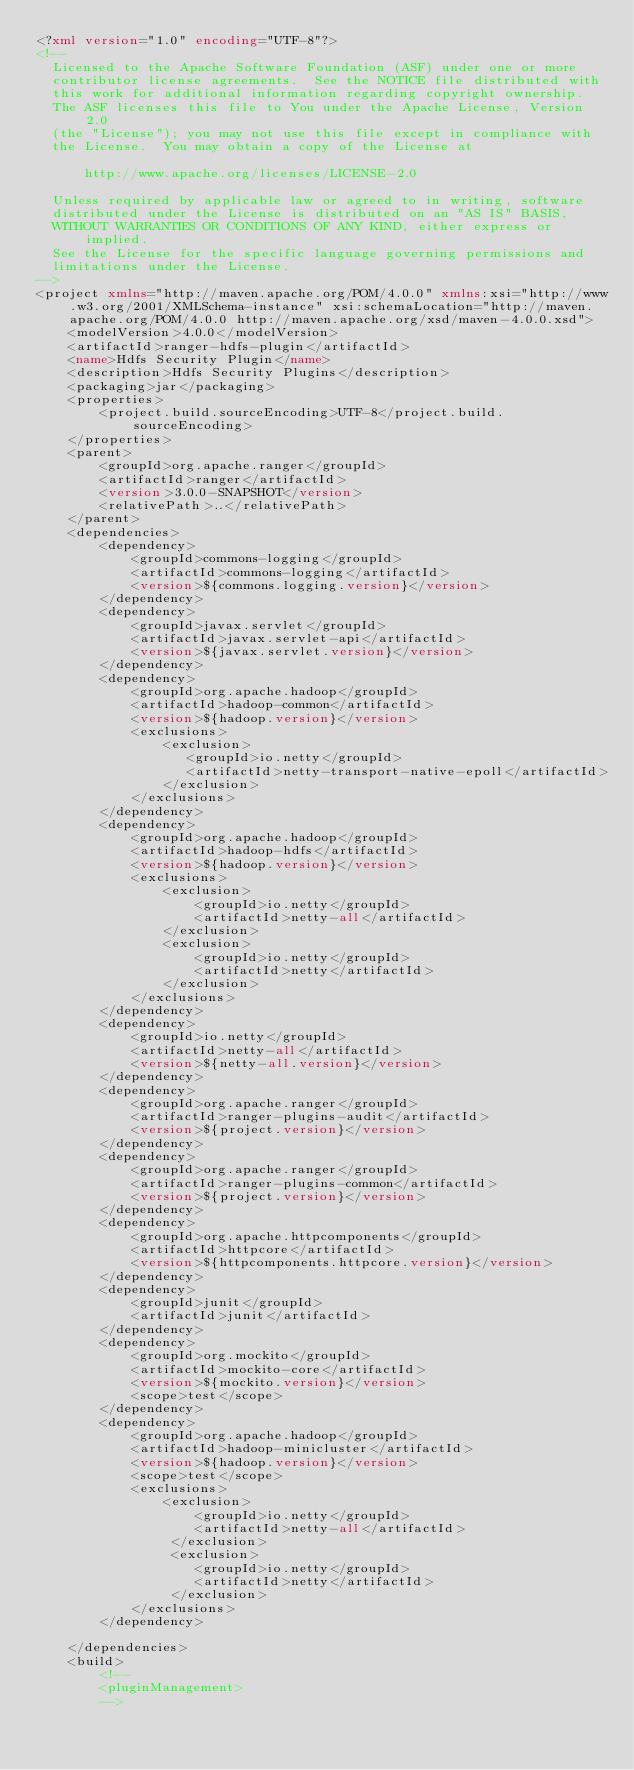<code> <loc_0><loc_0><loc_500><loc_500><_XML_><?xml version="1.0" encoding="UTF-8"?>
<!--
  Licensed to the Apache Software Foundation (ASF) under one or more
  contributor license agreements.  See the NOTICE file distributed with
  this work for additional information regarding copyright ownership.
  The ASF licenses this file to You under the Apache License, Version 2.0
  (the "License"); you may not use this file except in compliance with
  the License.  You may obtain a copy of the License at

      http://www.apache.org/licenses/LICENSE-2.0

  Unless required by applicable law or agreed to in writing, software
  distributed under the License is distributed on an "AS IS" BASIS,
  WITHOUT WARRANTIES OR CONDITIONS OF ANY KIND, either express or implied.
  See the License for the specific language governing permissions and
  limitations under the License.
-->
<project xmlns="http://maven.apache.org/POM/4.0.0" xmlns:xsi="http://www.w3.org/2001/XMLSchema-instance" xsi:schemaLocation="http://maven.apache.org/POM/4.0.0 http://maven.apache.org/xsd/maven-4.0.0.xsd">
    <modelVersion>4.0.0</modelVersion>
    <artifactId>ranger-hdfs-plugin</artifactId>
    <name>Hdfs Security Plugin</name>
    <description>Hdfs Security Plugins</description>
    <packaging>jar</packaging>
    <properties>
        <project.build.sourceEncoding>UTF-8</project.build.sourceEncoding>
    </properties>
    <parent>
        <groupId>org.apache.ranger</groupId>
        <artifactId>ranger</artifactId>
        <version>3.0.0-SNAPSHOT</version>
        <relativePath>..</relativePath>
    </parent>
    <dependencies>
        <dependency>
            <groupId>commons-logging</groupId>
            <artifactId>commons-logging</artifactId>
            <version>${commons.logging.version}</version>
        </dependency>
        <dependency>
            <groupId>javax.servlet</groupId>
            <artifactId>javax.servlet-api</artifactId>
            <version>${javax.servlet.version}</version>
        </dependency>
        <dependency>
            <groupId>org.apache.hadoop</groupId>
            <artifactId>hadoop-common</artifactId>
            <version>${hadoop.version}</version>
            <exclusions>
                <exclusion>
                   <groupId>io.netty</groupId>
                   <artifactId>netty-transport-native-epoll</artifactId>
                </exclusion>
            </exclusions>
        </dependency>
        <dependency>
            <groupId>org.apache.hadoop</groupId>
            <artifactId>hadoop-hdfs</artifactId>
            <version>${hadoop.version}</version>
            <exclusions>
                <exclusion>
                    <groupId>io.netty</groupId>
                    <artifactId>netty-all</artifactId>
                </exclusion>
                <exclusion>
                    <groupId>io.netty</groupId>
                    <artifactId>netty</artifactId>
                </exclusion>
            </exclusions>
        </dependency>
        <dependency>
            <groupId>io.netty</groupId>
            <artifactId>netty-all</artifactId>
            <version>${netty-all.version}</version>
        </dependency>
        <dependency>
            <groupId>org.apache.ranger</groupId>
            <artifactId>ranger-plugins-audit</artifactId>
            <version>${project.version}</version>
        </dependency>
        <dependency>
            <groupId>org.apache.ranger</groupId>
            <artifactId>ranger-plugins-common</artifactId>
            <version>${project.version}</version>
        </dependency>
        <dependency>
    		<groupId>org.apache.httpcomponents</groupId>
    		<artifactId>httpcore</artifactId>
    		<version>${httpcomponents.httpcore.version}</version>
		</dependency>
        <dependency>
            <groupId>junit</groupId>
            <artifactId>junit</artifactId>
        </dependency>
        <dependency>
            <groupId>org.mockito</groupId>
            <artifactId>mockito-core</artifactId>
            <version>${mockito.version}</version>
            <scope>test</scope>
        </dependency>
        <dependency>
            <groupId>org.apache.hadoop</groupId>
            <artifactId>hadoop-minicluster</artifactId>
            <version>${hadoop.version}</version>
            <scope>test</scope>
            <exclusions>
                <exclusion>
                    <groupId>io.netty</groupId>
                    <artifactId>netty-all</artifactId>
                 </exclusion>
                 <exclusion>
                    <groupId>io.netty</groupId>
                    <artifactId>netty</artifactId>
                 </exclusion>
            </exclusions>
        </dependency>

    </dependencies>
    <build>
        <!--
        <pluginManagement>
        --></code> 